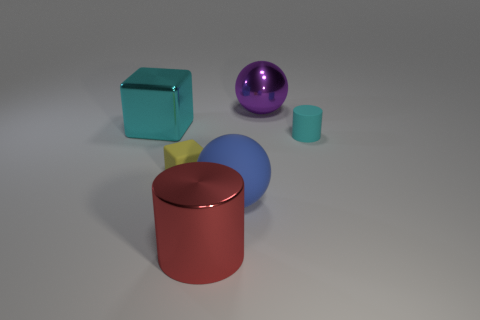Can you describe the lighting in this scene? The lighting in this scene is quite soft, creating gentle shadows and subtle highlights on the objects. There's likely a single, diffused light source positioned above and possibly slightly to the front, considering how the shadows are cast behind and to the right of the objects, indicating the light comes from the left. The image doesn't show harsh shadows or extreme contrasts, which supports the idea of a soft and diffused lighting environment, highlighting the colors and materials of the objects without creating glare. 